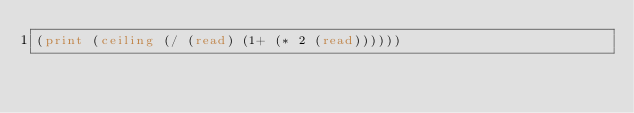Convert code to text. <code><loc_0><loc_0><loc_500><loc_500><_Lisp_>(print (ceiling (/ (read) (1+ (* 2 (read))))))</code> 